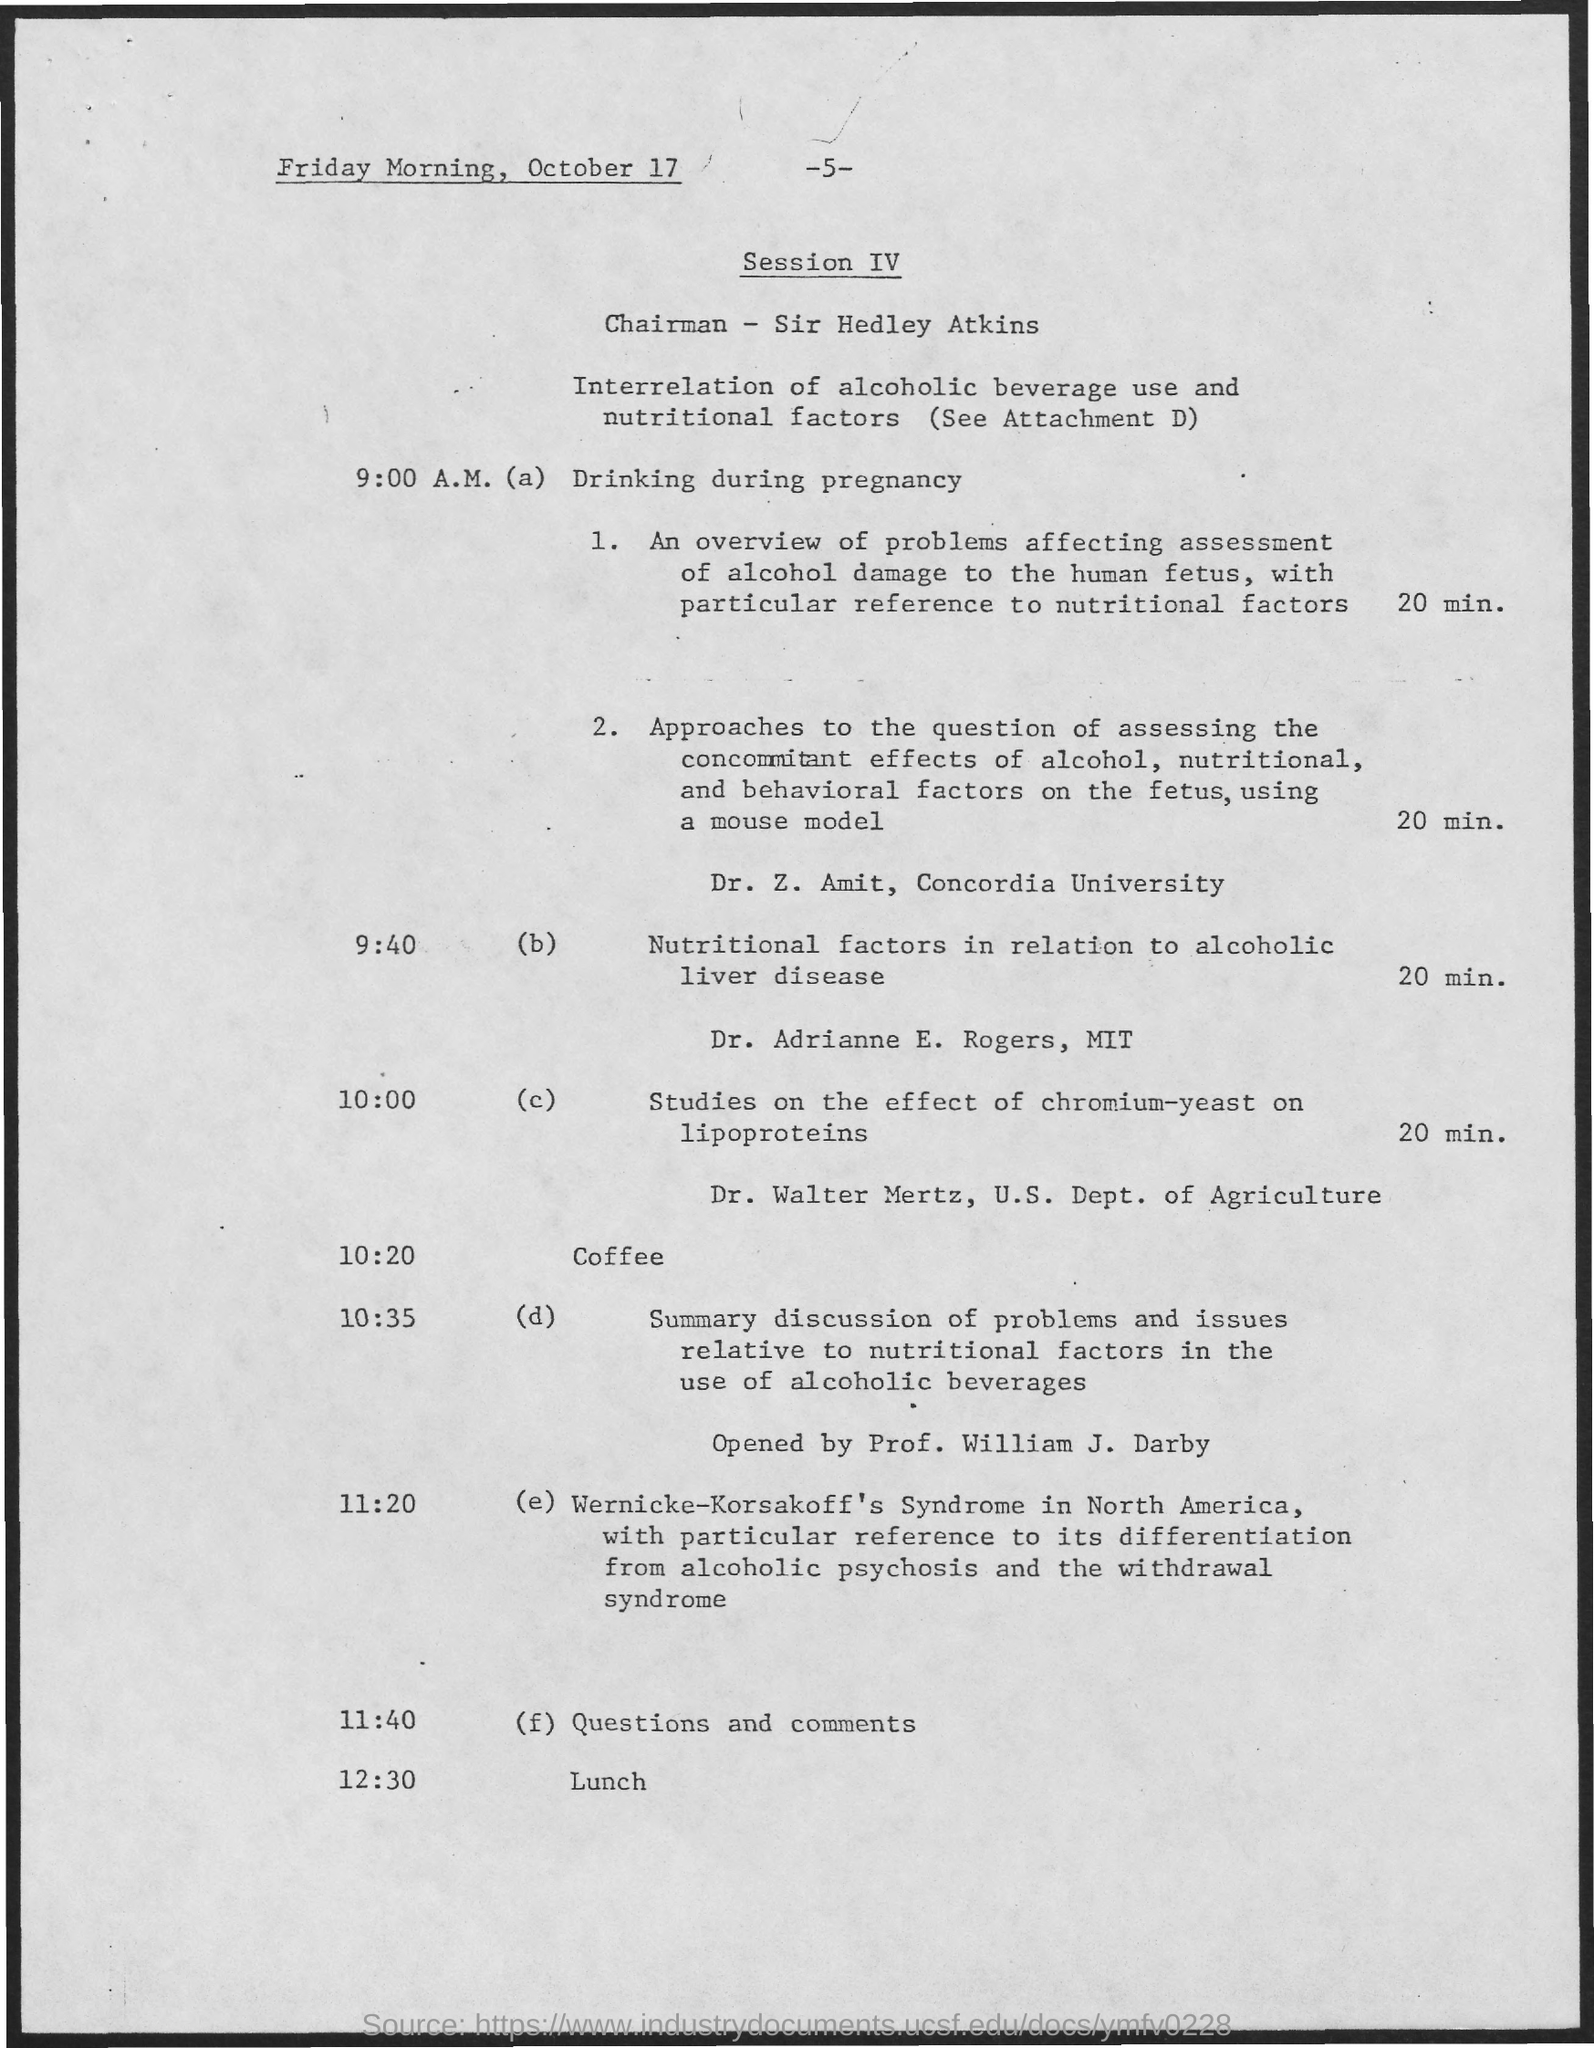What is the day and date mentioned at the top?
Offer a terse response. Friday morning, October 17. What is the page number?
Make the answer very short. 5. Who is the chairman?
Your response must be concise. Sir hedley atkins. What is the topic for 9:00 a.m.?
Provide a short and direct response. Drinking during pregnancy. Who will be presenting at 9:40?
Offer a very short reply. Dr. adriamne e. rogers. What is the duartion dr. adriamne e. rogers will be presenting for?
Provide a succinct answer. 20 min. What is the time for questions and comments?
Keep it short and to the point. 11:40. What is the topic of the session iv?
Give a very brief answer. Interrelation of alcoholic beverage use and nutritional factors. 